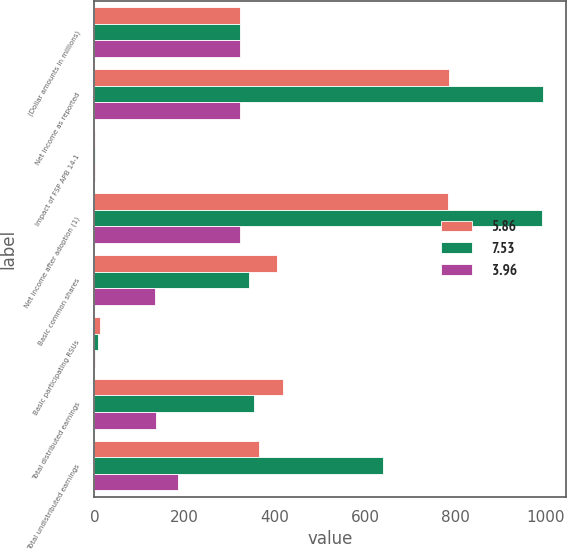Convert chart to OTSL. <chart><loc_0><loc_0><loc_500><loc_500><stacked_bar_chart><ecel><fcel>(Dollar amounts in millions)<fcel>Net income as reported<fcel>Impact of FSP APB 14-1<fcel>Net income after adoption (1)<fcel>Basic common shares<fcel>Basic participating RSUs<fcel>Total distributed earnings<fcel>Total undistributed earnings<nl><fcel>5.86<fcel>323<fcel>786<fcel>2<fcel>784<fcel>405<fcel>13<fcel>418<fcel>366<nl><fcel>7.53<fcel>323<fcel>995<fcel>2<fcel>993<fcel>344<fcel>9<fcel>353<fcel>640<nl><fcel>3.96<fcel>323<fcel>323<fcel>1<fcel>322<fcel>135<fcel>1<fcel>136<fcel>186<nl></chart> 